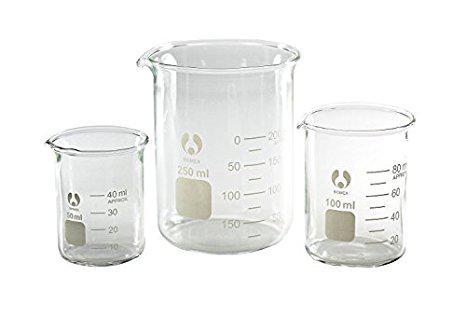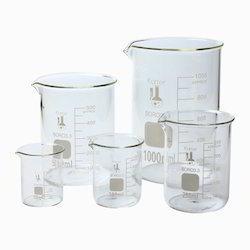The first image is the image on the left, the second image is the image on the right. Given the left and right images, does the statement "Exactly five beakers in one image and three in the other image are all empty and different sizes." hold true? Answer yes or no. Yes. The first image is the image on the left, the second image is the image on the right. Given the left and right images, does the statement "There are exactly 3 beakers in one of the images." hold true? Answer yes or no. Yes. 